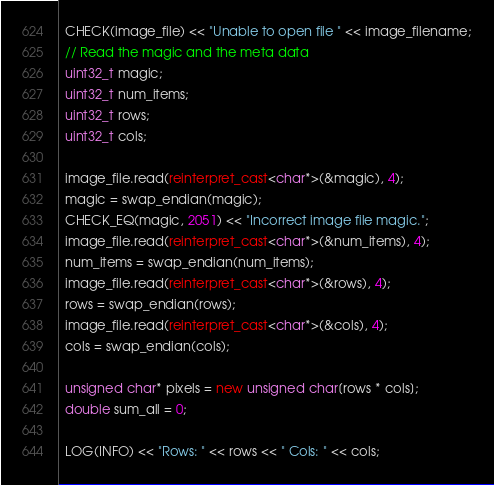<code> <loc_0><loc_0><loc_500><loc_500><_C++_>  CHECK(image_file) << "Unable to open file " << image_filename;
  // Read the magic and the meta data
  uint32_t magic;
  uint32_t num_items;
  uint32_t rows;
  uint32_t cols;

  image_file.read(reinterpret_cast<char*>(&magic), 4);
  magic = swap_endian(magic);
  CHECK_EQ(magic, 2051) << "Incorrect image file magic.";
  image_file.read(reinterpret_cast<char*>(&num_items), 4);
  num_items = swap_endian(num_items);
  image_file.read(reinterpret_cast<char*>(&rows), 4);
  rows = swap_endian(rows);
  image_file.read(reinterpret_cast<char*>(&cols), 4);
  cols = swap_endian(cols);

  unsigned char* pixels = new unsigned char[rows * cols];
  double sum_all = 0;

  LOG(INFO) << "Rows: " << rows << " Cols: " << cols;</code> 